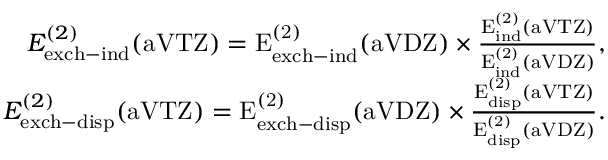Convert formula to latex. <formula><loc_0><loc_0><loc_500><loc_500>\begin{array} { r } { E _ { e x c h - i n d } ^ { ( 2 ) } ( a V T Z ) = E _ { \mathrm { e x c h - i n d } } ^ { ( 2 ) } ( \mathrm { a V D Z ) \times \frac { E _ { \mathrm { i n d } } ^ { ( 2 ) } ( \mathrm { a V T Z ) } } { E _ { \mathrm { i n d } } ^ { ( 2 ) } ( \mathrm { a V D Z ) } } , } } \\ { E _ { e x c h - d i s p } ^ { ( 2 ) } ( a V T Z ) = E _ { \mathrm { e x c h - d i s p } } ^ { ( 2 ) } ( \mathrm { a V D Z ) \times \frac { E _ { \mathrm { d i s p } } ^ { ( 2 ) } ( \mathrm { a V T Z ) } } { E _ { \mathrm { d i s p } } ^ { ( 2 ) } ( \mathrm { a V D Z ) } } . } } \end{array}</formula> 